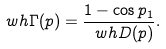<formula> <loc_0><loc_0><loc_500><loc_500>\ w h \Gamma ( p ) = \frac { 1 - \cos p _ { 1 } } { \ w h D ( p ) } .</formula> 